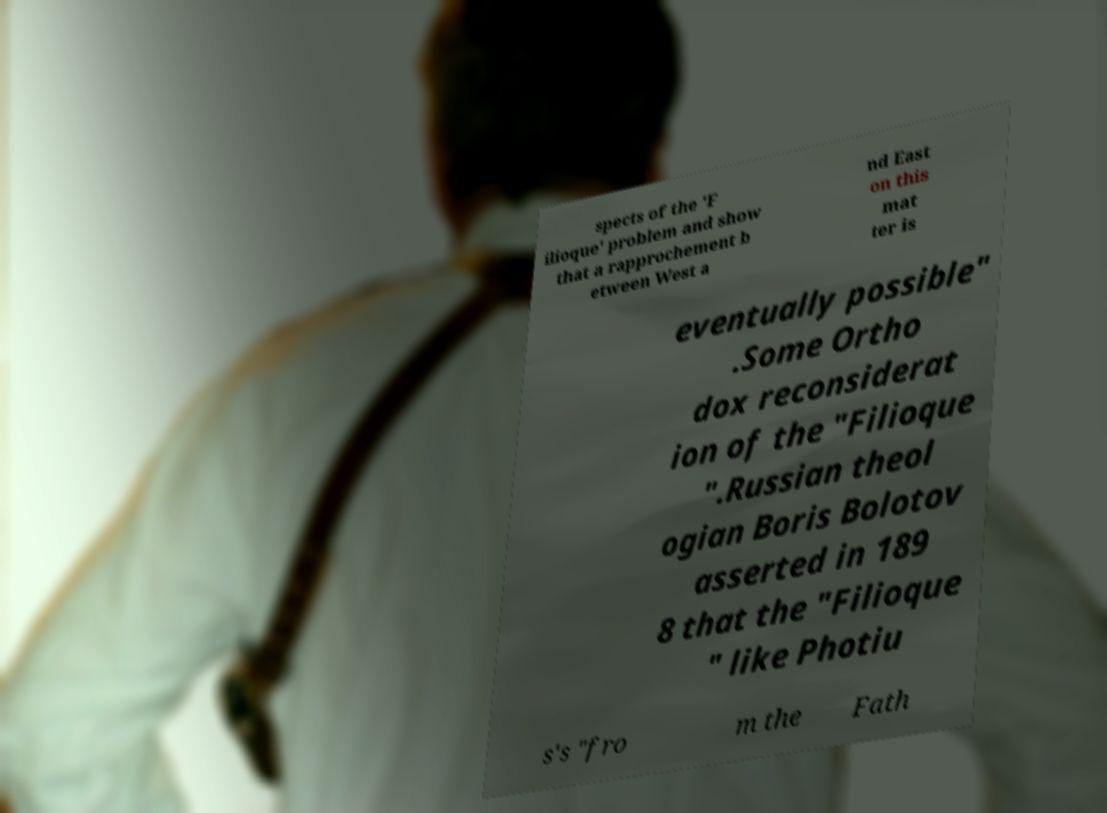Please identify and transcribe the text found in this image. spects of the 'F ilioque' problem and show that a rapprochement b etween West a nd East on this mat ter is eventually possible" .Some Ortho dox reconsiderat ion of the "Filioque ".Russian theol ogian Boris Bolotov asserted in 189 8 that the "Filioque " like Photiu s's "fro m the Fath 